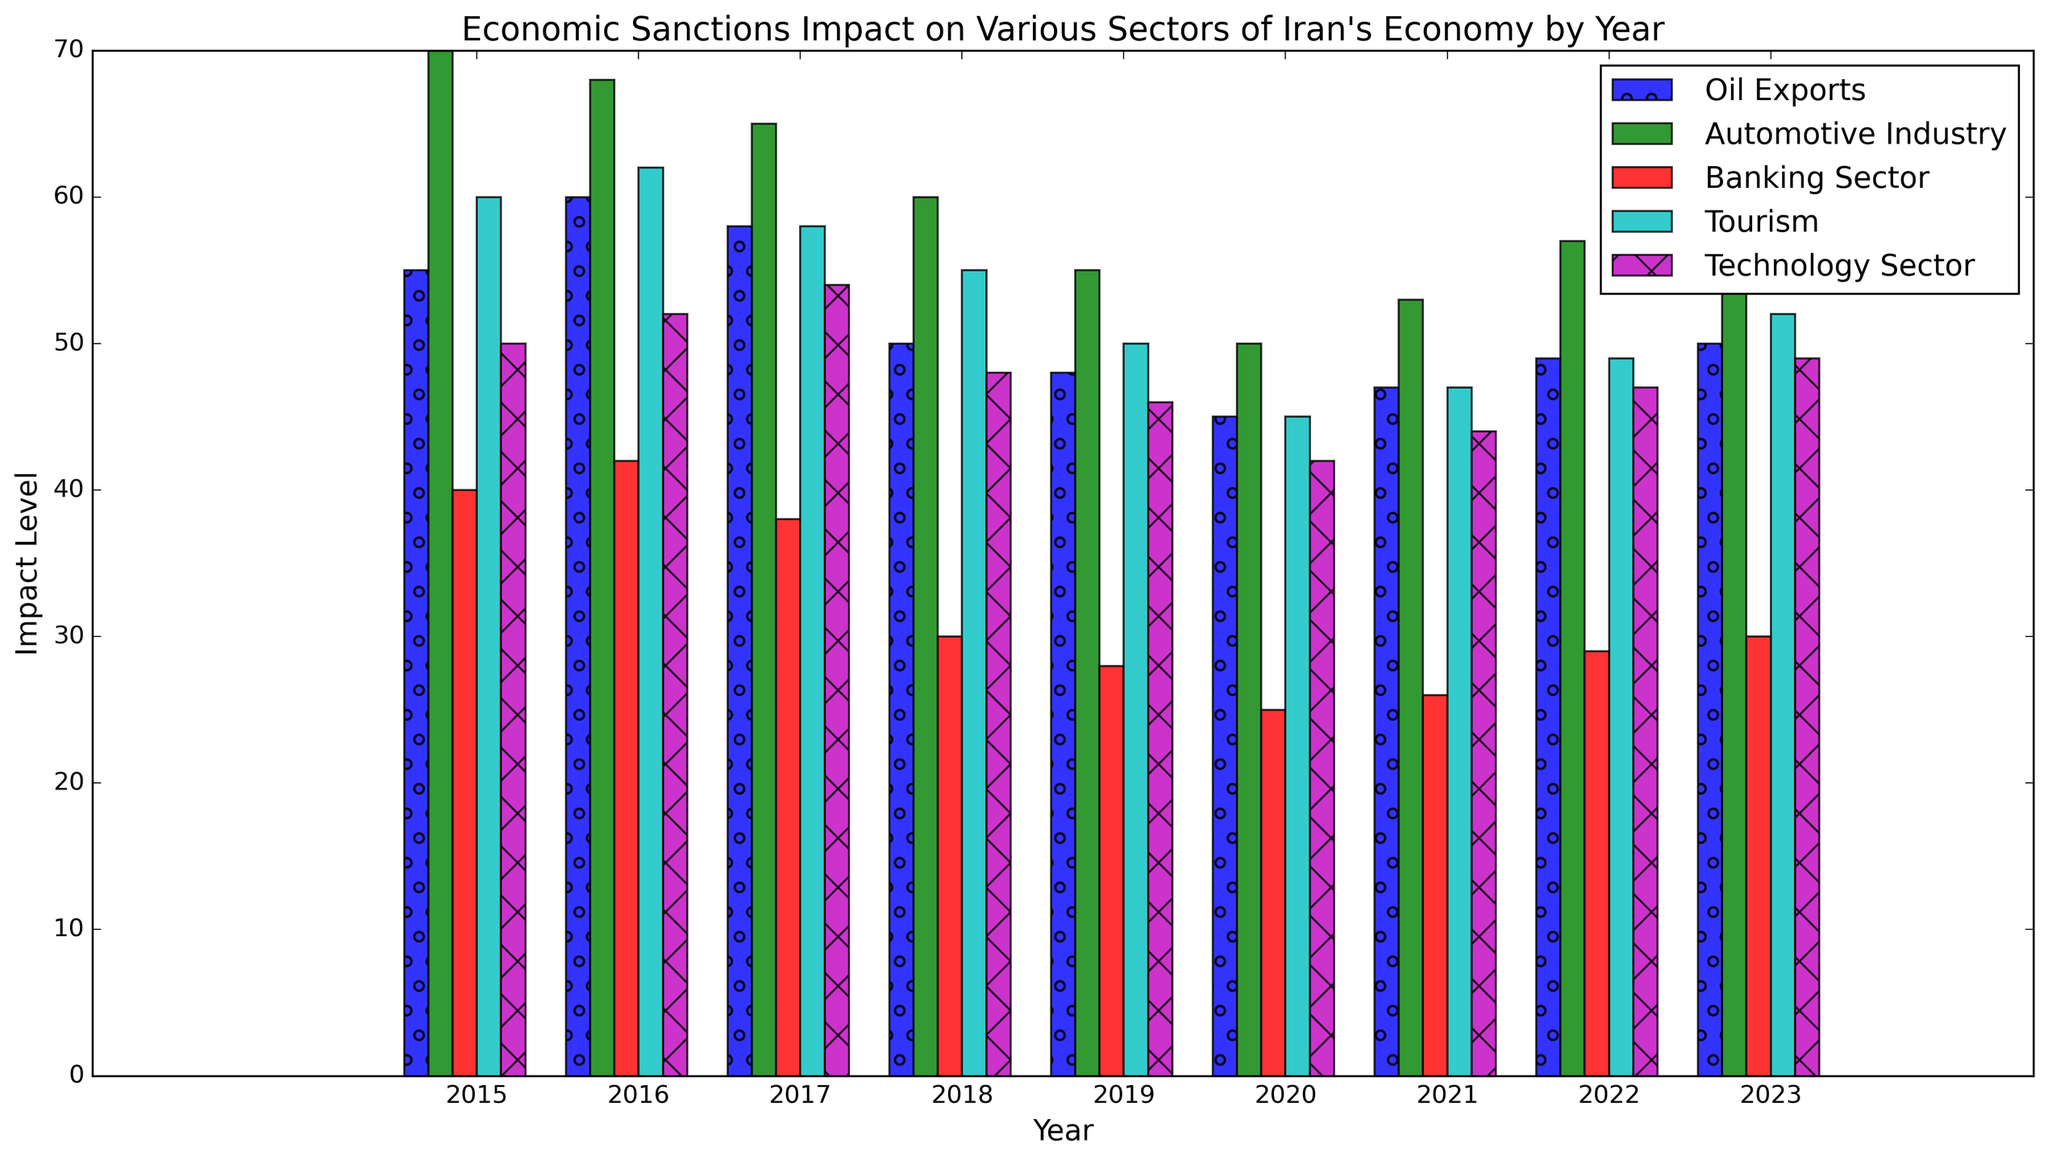What sector experienced the largest percentage decline from 2015 to 2020? First, note the impact levels for each sector in 2015 and 2020. Percentage decline is calculated as ((2015 value - 2020 value) / 2015 value) * 100. Calculate the percentage decline for each sector: Oil Exports: ((55 - 45) / 55) * 100 = ~18.18%, Automotive Industry: ((70 - 50) / 70) * 100 = ~28.57%, Banking Sector: ((40 - 25) / 40) * 100 = ~37.5%, Tourism: ((60 - 45) / 60) * 100 = 25%, Technology Sector: ((50 - 42) / 50) * 100 = 16%. The Banking Sector has the largest decline at 37.5%.
Answer: Banking Sector Which sector showed the most consistent impact level from 2015 to 2023? Look at the bars' heights for each sector across all years. Consistent levels mean smaller variations over the years. The Technology Sector shows a relatively steady impact level with minor fluctuations compared to other sectors.
Answer: Technology Sector How did the Tourism sector change from 2018 to 2020? Compare the heights of the bars for the Tourism sector in 2018 (55), 2019 (50), and 2020 (45). Notice the consistent decrease across these years.
Answer: Decreased Which year had the lowest overall impact level across all sectors? Sum the impacts for all sectors per year. Calculate the totals: 2015 (275), 2016 (284), 2017 (273), 2018 (243), 2019 (227), 2020 (207), 2021 (217), 2022 (231), 2023 (241). The year 2020 has the lowest total impact level at 207.
Answer: 2020 How did the impact on Oil Exports change after 2016? Look at the bars for Oil Exports from 2016 onwards. In 2016 the level was 60 and then it decreased to 58 in 2017, 50 in 2018, 48 in 2019, 45 in 2020, slightly increased to 47 in 2021, 49 in 2022, and 50 in 2023. Overall, it shows a downward trend with slight increases towards the end.
Answer: Decreased with slight increases What was the impact difference between the Automotive Industry and Technology Sector in 2023? Note the values for the Automotive Industry (60) and Technology Sector (49) in 2023. The difference is 60 - 49 = 11.
Answer: 11 Which year saw the highest impact in the Banking Sector? Compare the heights of the bars for the Banking Sector across all years. The highest is in 2016, with an impact level of 42.
Answer: 2016 How many sectors saw a lower impact in 2020 compared to 2015? Compare the 2015 and 2020 values for each sector: Oil Exports: 55 vs 45; Automotive Industry: 70 vs 50; Banking Sector: 40 vs 25; Tourism: 60 vs 45; Technology Sector: 50 vs 42. All sectors have lower impact levels in 2020 compared to 2015.
Answer: 5 sectors 